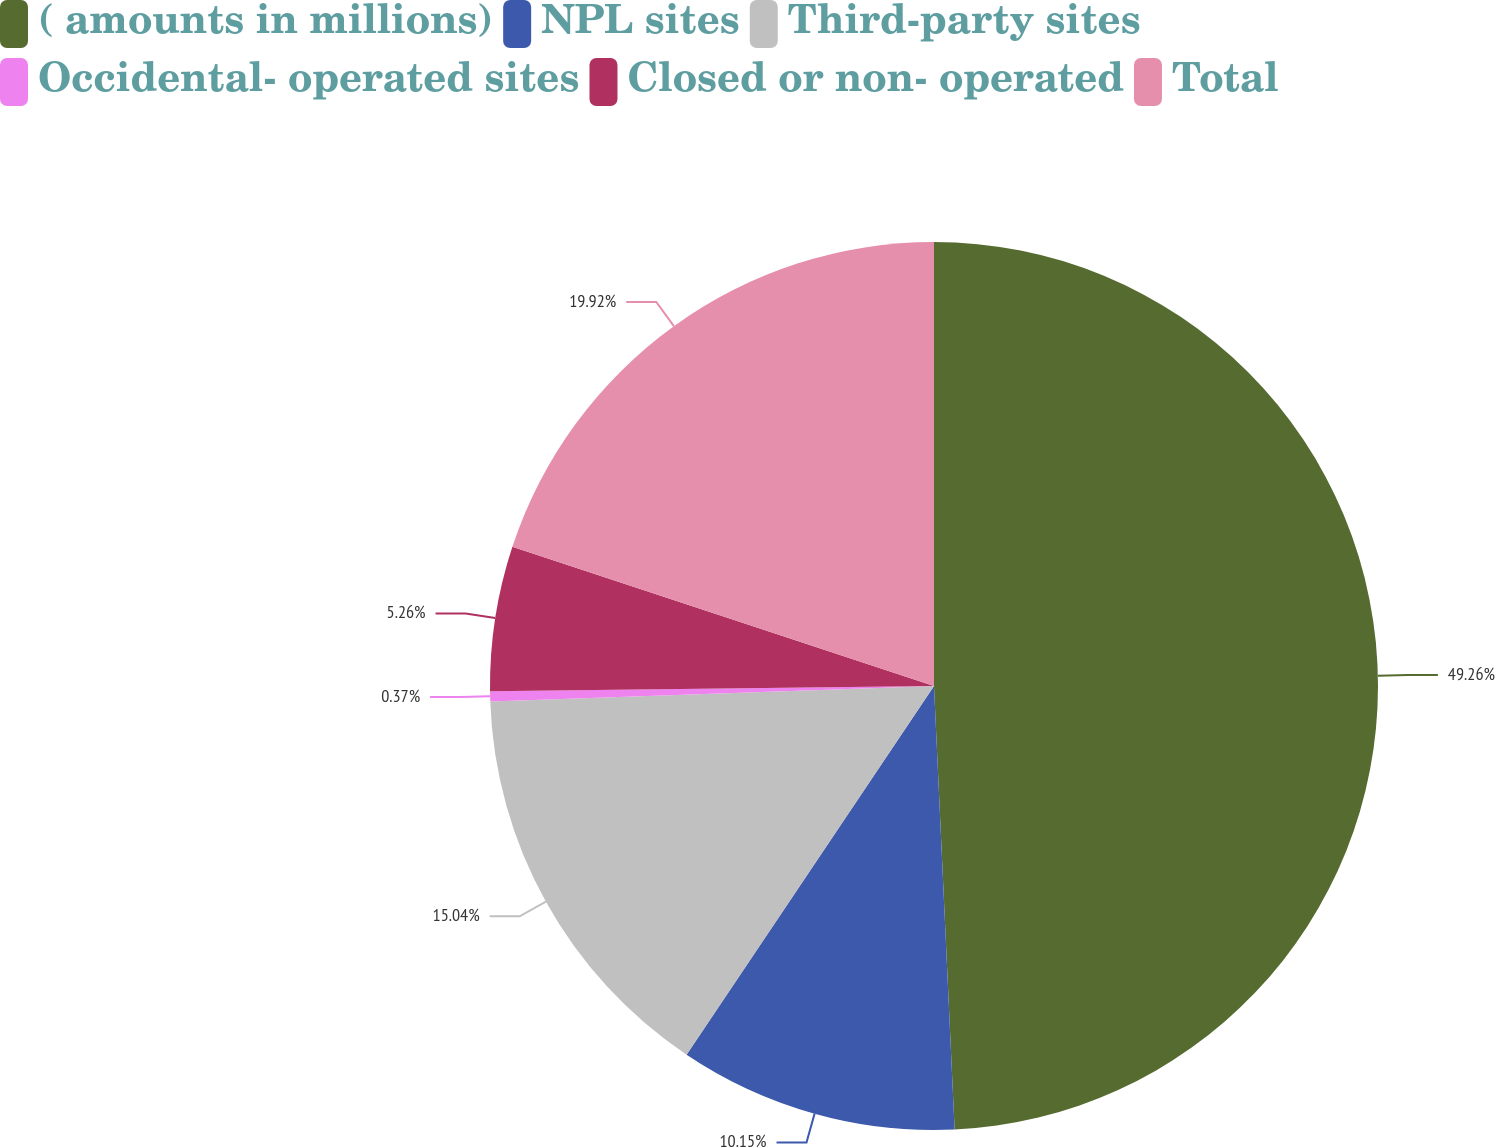Convert chart. <chart><loc_0><loc_0><loc_500><loc_500><pie_chart><fcel>( amounts in millions)<fcel>NPL sites<fcel>Third-party sites<fcel>Occidental- operated sites<fcel>Closed or non- operated<fcel>Total<nl><fcel>49.27%<fcel>10.15%<fcel>15.04%<fcel>0.37%<fcel>5.26%<fcel>19.93%<nl></chart> 